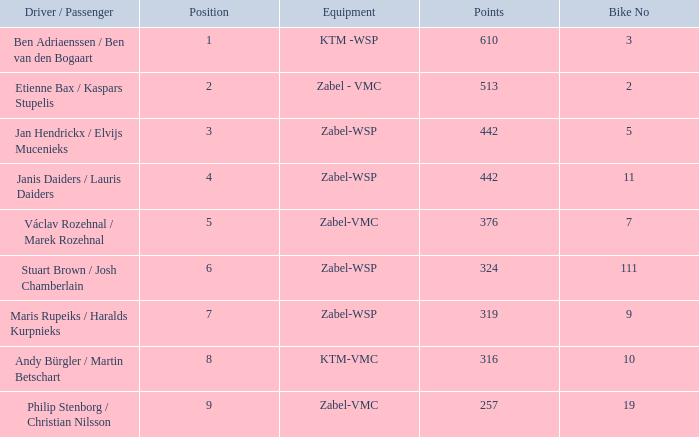What are the points for ktm-vmc equipment?  316.0. 